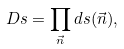<formula> <loc_0><loc_0><loc_500><loc_500>D s = \prod _ { \vec { n } } d s ( \vec { n } ) ,</formula> 